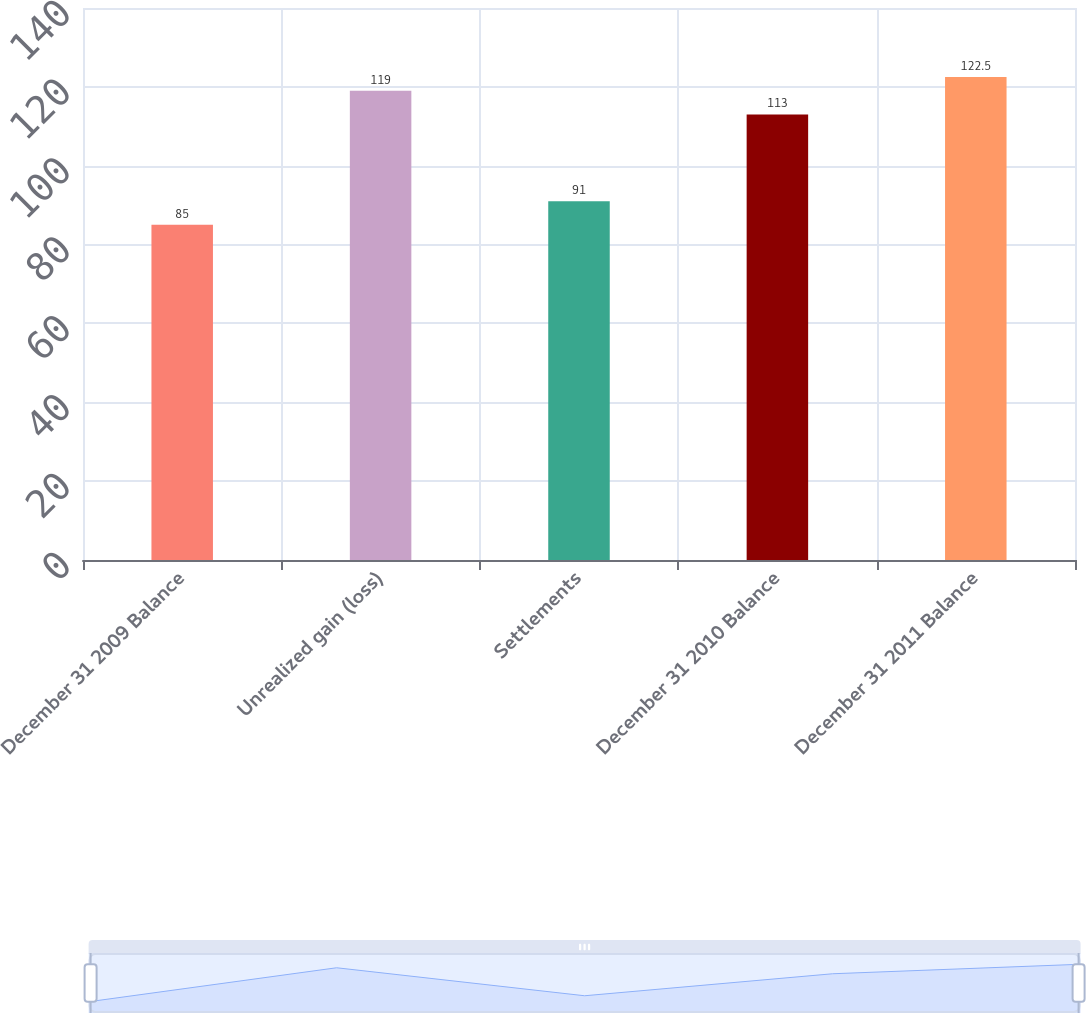<chart> <loc_0><loc_0><loc_500><loc_500><bar_chart><fcel>December 31 2009 Balance<fcel>Unrealized gain (loss)<fcel>Settlements<fcel>December 31 2010 Balance<fcel>December 31 2011 Balance<nl><fcel>85<fcel>119<fcel>91<fcel>113<fcel>122.5<nl></chart> 